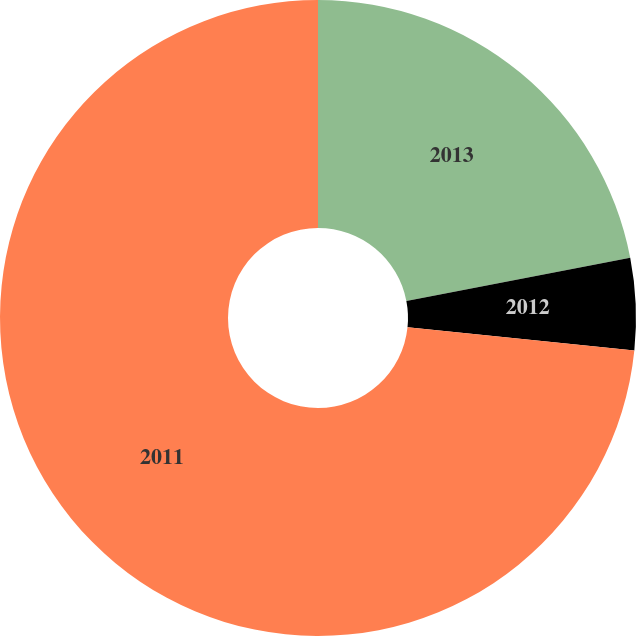Convert chart to OTSL. <chart><loc_0><loc_0><loc_500><loc_500><pie_chart><fcel>2013<fcel>2012<fcel>2011<nl><fcel>21.96%<fcel>4.67%<fcel>73.36%<nl></chart> 